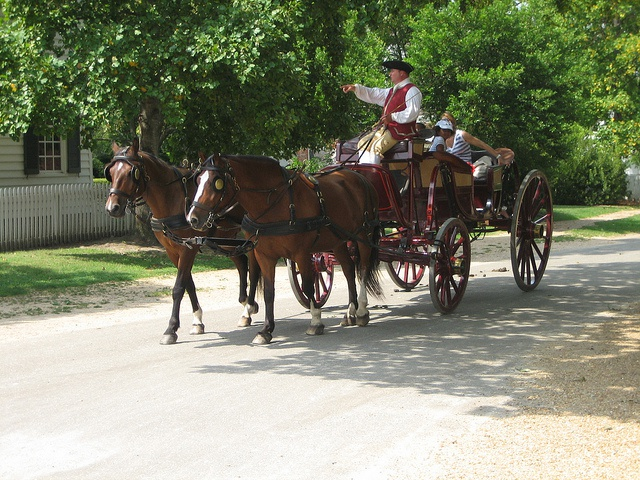Describe the objects in this image and their specific colors. I can see horse in olive, black, maroon, and gray tones, horse in olive, black, maroon, and gray tones, people in olive, darkgray, maroon, lightgray, and gray tones, people in olive, gray, maroon, and black tones, and people in olive, black, maroon, darkgray, and gray tones in this image. 